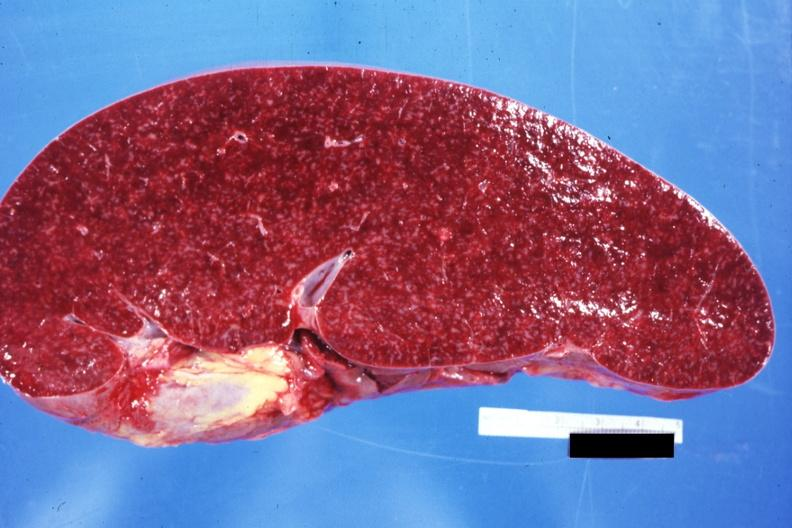does normal see other sides this case?
Answer the question using a single word or phrase. Yes 